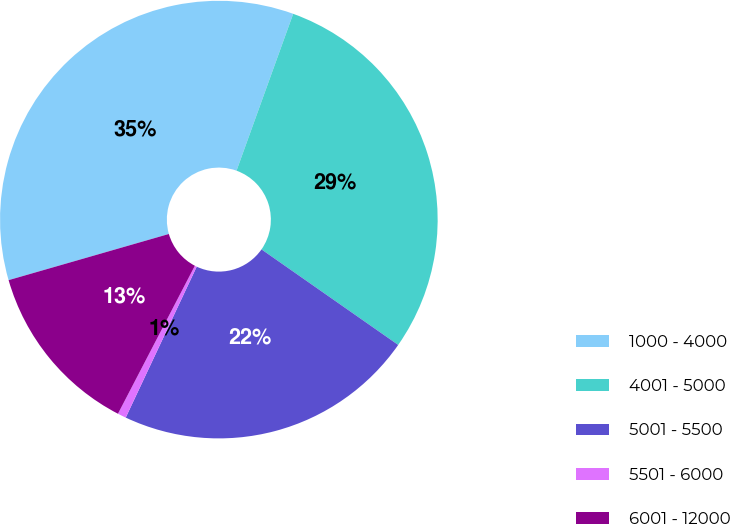Convert chart. <chart><loc_0><loc_0><loc_500><loc_500><pie_chart><fcel>1000 - 4000<fcel>4001 - 5000<fcel>5001 - 5500<fcel>5501 - 6000<fcel>6001 - 12000<nl><fcel>34.98%<fcel>29.19%<fcel>22.29%<fcel>0.63%<fcel>12.91%<nl></chart> 